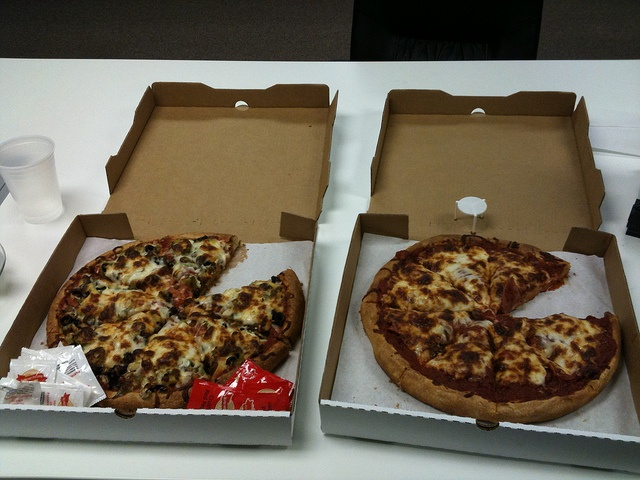Describe the objects in this image and their specific colors. I can see dining table in black, lightgray, darkgray, and gray tones, pizza in black, maroon, and olive tones, pizza in black, maroon, olive, and tan tones, and cup in black, lightgray, and darkgray tones in this image. 